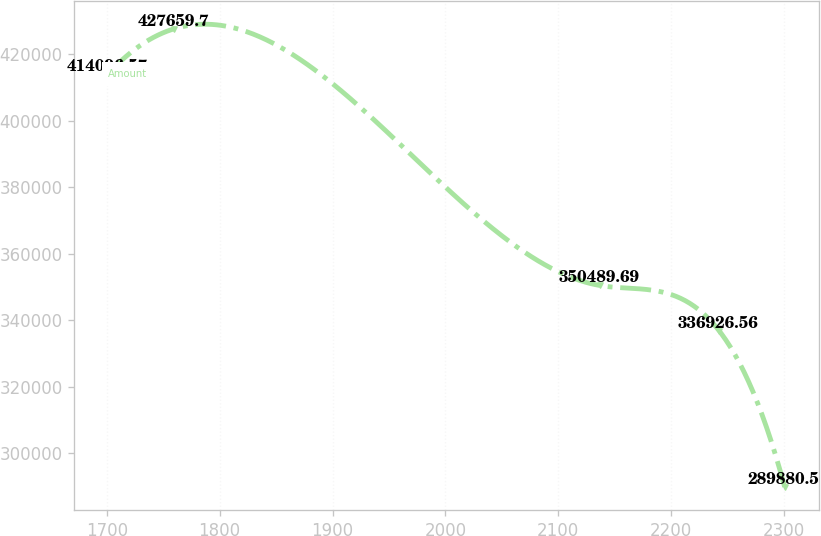<chart> <loc_0><loc_0><loc_500><loc_500><line_chart><ecel><fcel>Amount<nl><fcel>1701.16<fcel>414097<nl><fcel>1759.38<fcel>427660<nl><fcel>2136.64<fcel>350490<nl><fcel>2242.42<fcel>336927<nl><fcel>2300.64<fcel>289880<nl></chart> 